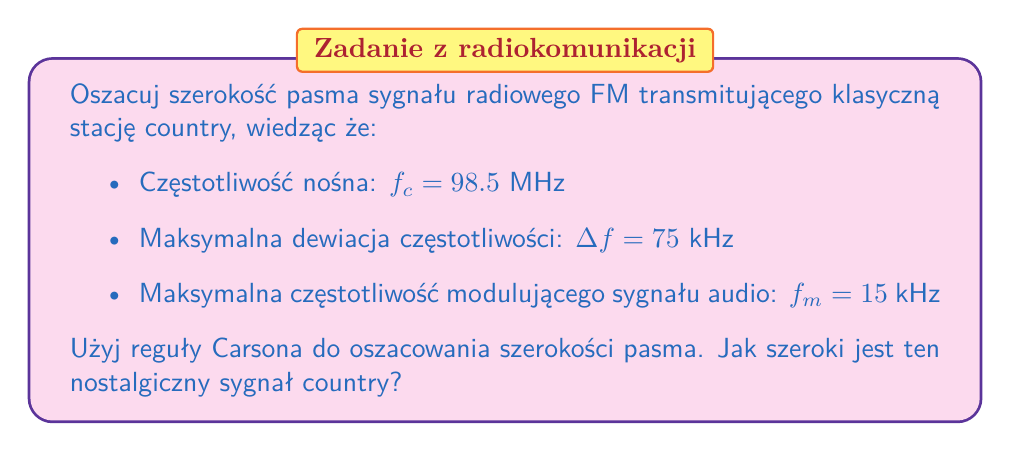Help me with this question. Aby oszacować szerokość pasma sygnału FM, użyjemy reguły Carsona:

1) Reguła Carsona określa szerokość pasma $B$ jako:

   $$ B = 2(\Delta f + f_m) $$

   gdzie $\Delta f$ to maksymalna dewiacja częstotliwości, a $f_m$ to maksymalna częstotliwość modulującego sygnału audio.

2) Podstawiamy dane do wzoru:
   
   $$ B = 2(75 \text{ kHz} + 15 \text{ kHz}) $$

3) Obliczamy:

   $$ B = 2(90 \text{ kHz}) = 180 \text{ kHz} $$

4) Zaokrąglamy wynik do najbliższej liczby całkowitej:

   $$ B \approx 180 \text{ kHz} $$

Tak więc, szerokość pasma sygnału FM transmitującego klasyczną stację country wynosi około 180 kHz.
Answer: 180 kHz 